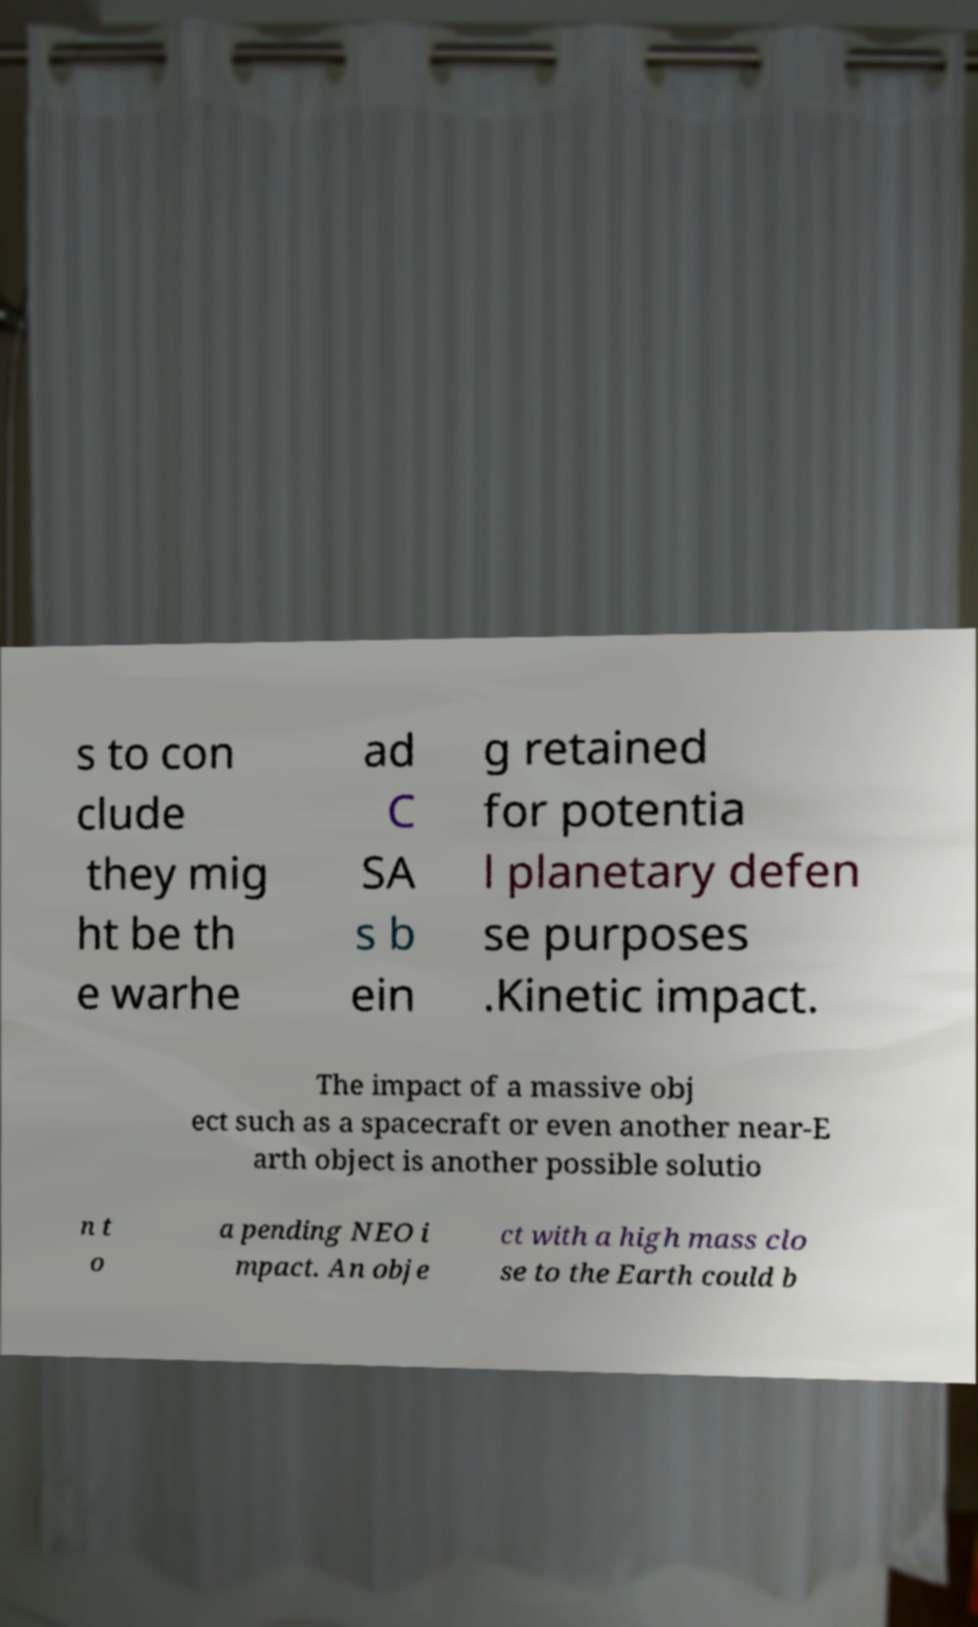Please identify and transcribe the text found in this image. s to con clude they mig ht be th e warhe ad C SA s b ein g retained for potentia l planetary defen se purposes .Kinetic impact. The impact of a massive obj ect such as a spacecraft or even another near-E arth object is another possible solutio n t o a pending NEO i mpact. An obje ct with a high mass clo se to the Earth could b 